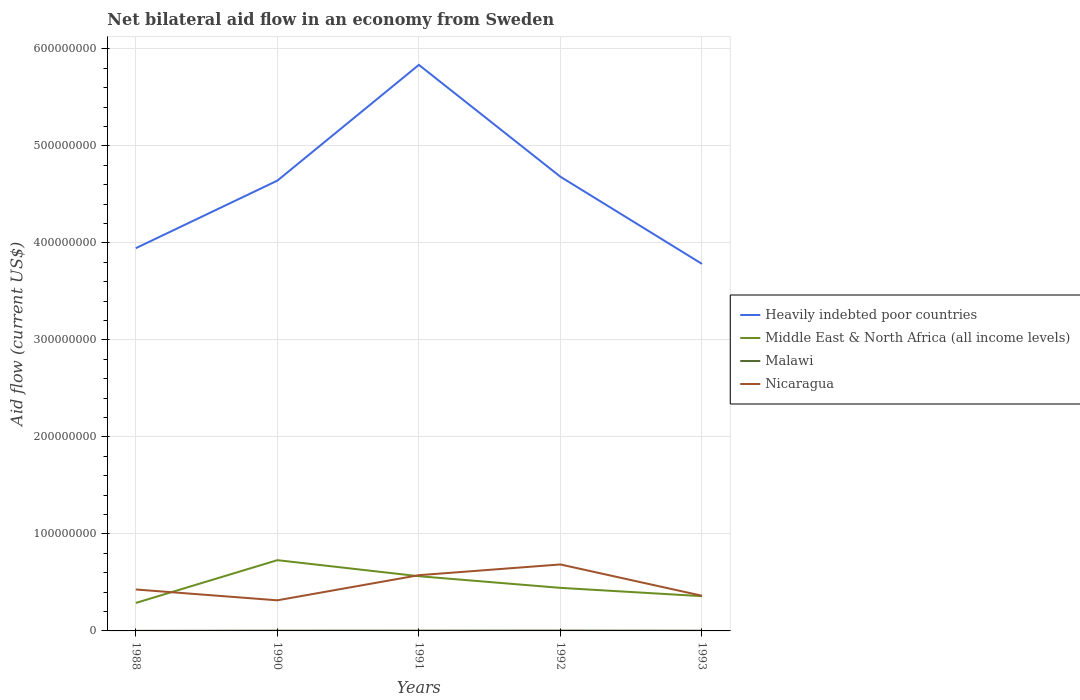Does the line corresponding to Nicaragua intersect with the line corresponding to Malawi?
Make the answer very short. No. In which year was the net bilateral aid flow in Heavily indebted poor countries maximum?
Provide a succinct answer. 1993. What is the total net bilateral aid flow in Middle East & North Africa (all income levels) in the graph?
Your answer should be very brief. 2.06e+07. What is the difference between the highest and the second highest net bilateral aid flow in Nicaragua?
Keep it short and to the point. 3.70e+07. How many years are there in the graph?
Make the answer very short. 5. What is the difference between two consecutive major ticks on the Y-axis?
Your answer should be very brief. 1.00e+08. Are the values on the major ticks of Y-axis written in scientific E-notation?
Keep it short and to the point. No. Does the graph contain grids?
Provide a succinct answer. Yes. Where does the legend appear in the graph?
Provide a succinct answer. Center right. How many legend labels are there?
Your answer should be compact. 4. How are the legend labels stacked?
Your answer should be very brief. Vertical. What is the title of the graph?
Your answer should be compact. Net bilateral aid flow in an economy from Sweden. What is the label or title of the Y-axis?
Ensure brevity in your answer.  Aid flow (current US$). What is the Aid flow (current US$) in Heavily indebted poor countries in 1988?
Make the answer very short. 3.95e+08. What is the Aid flow (current US$) in Middle East & North Africa (all income levels) in 1988?
Provide a short and direct response. 2.88e+07. What is the Aid flow (current US$) of Nicaragua in 1988?
Your answer should be very brief. 4.27e+07. What is the Aid flow (current US$) in Heavily indebted poor countries in 1990?
Make the answer very short. 4.64e+08. What is the Aid flow (current US$) in Middle East & North Africa (all income levels) in 1990?
Provide a succinct answer. 7.29e+07. What is the Aid flow (current US$) in Nicaragua in 1990?
Give a very brief answer. 3.16e+07. What is the Aid flow (current US$) in Heavily indebted poor countries in 1991?
Offer a terse response. 5.84e+08. What is the Aid flow (current US$) in Middle East & North Africa (all income levels) in 1991?
Make the answer very short. 5.64e+07. What is the Aid flow (current US$) in Malawi in 1991?
Provide a short and direct response. 2.90e+05. What is the Aid flow (current US$) in Nicaragua in 1991?
Make the answer very short. 5.75e+07. What is the Aid flow (current US$) of Heavily indebted poor countries in 1992?
Provide a short and direct response. 4.68e+08. What is the Aid flow (current US$) in Middle East & North Africa (all income levels) in 1992?
Keep it short and to the point. 4.44e+07. What is the Aid flow (current US$) in Malawi in 1992?
Your answer should be very brief. 3.50e+05. What is the Aid flow (current US$) of Nicaragua in 1992?
Your answer should be compact. 6.85e+07. What is the Aid flow (current US$) of Heavily indebted poor countries in 1993?
Keep it short and to the point. 3.78e+08. What is the Aid flow (current US$) in Middle East & North Africa (all income levels) in 1993?
Your answer should be very brief. 3.58e+07. What is the Aid flow (current US$) in Nicaragua in 1993?
Keep it short and to the point. 3.63e+07. Across all years, what is the maximum Aid flow (current US$) in Heavily indebted poor countries?
Your response must be concise. 5.84e+08. Across all years, what is the maximum Aid flow (current US$) in Middle East & North Africa (all income levels)?
Your answer should be very brief. 7.29e+07. Across all years, what is the maximum Aid flow (current US$) in Malawi?
Offer a terse response. 3.50e+05. Across all years, what is the maximum Aid flow (current US$) of Nicaragua?
Provide a short and direct response. 6.85e+07. Across all years, what is the minimum Aid flow (current US$) in Heavily indebted poor countries?
Ensure brevity in your answer.  3.78e+08. Across all years, what is the minimum Aid flow (current US$) of Middle East & North Africa (all income levels)?
Provide a succinct answer. 2.88e+07. Across all years, what is the minimum Aid flow (current US$) in Malawi?
Provide a short and direct response. 8.00e+04. Across all years, what is the minimum Aid flow (current US$) of Nicaragua?
Keep it short and to the point. 3.16e+07. What is the total Aid flow (current US$) in Heavily indebted poor countries in the graph?
Your response must be concise. 2.29e+09. What is the total Aid flow (current US$) in Middle East & North Africa (all income levels) in the graph?
Keep it short and to the point. 2.38e+08. What is the total Aid flow (current US$) in Malawi in the graph?
Your answer should be very brief. 1.19e+06. What is the total Aid flow (current US$) of Nicaragua in the graph?
Provide a short and direct response. 2.37e+08. What is the difference between the Aid flow (current US$) in Heavily indebted poor countries in 1988 and that in 1990?
Your answer should be compact. -6.96e+07. What is the difference between the Aid flow (current US$) of Middle East & North Africa (all income levels) in 1988 and that in 1990?
Provide a short and direct response. -4.41e+07. What is the difference between the Aid flow (current US$) of Malawi in 1988 and that in 1990?
Your answer should be compact. -1.70e+05. What is the difference between the Aid flow (current US$) of Nicaragua in 1988 and that in 1990?
Ensure brevity in your answer.  1.12e+07. What is the difference between the Aid flow (current US$) of Heavily indebted poor countries in 1988 and that in 1991?
Keep it short and to the point. -1.89e+08. What is the difference between the Aid flow (current US$) in Middle East & North Africa (all income levels) in 1988 and that in 1991?
Give a very brief answer. -2.76e+07. What is the difference between the Aid flow (current US$) in Nicaragua in 1988 and that in 1991?
Offer a very short reply. -1.47e+07. What is the difference between the Aid flow (current US$) in Heavily indebted poor countries in 1988 and that in 1992?
Your response must be concise. -7.37e+07. What is the difference between the Aid flow (current US$) in Middle East & North Africa (all income levels) in 1988 and that in 1992?
Provide a succinct answer. -1.56e+07. What is the difference between the Aid flow (current US$) of Malawi in 1988 and that in 1992?
Ensure brevity in your answer.  -2.70e+05. What is the difference between the Aid flow (current US$) in Nicaragua in 1988 and that in 1992?
Give a very brief answer. -2.58e+07. What is the difference between the Aid flow (current US$) of Heavily indebted poor countries in 1988 and that in 1993?
Your response must be concise. 1.62e+07. What is the difference between the Aid flow (current US$) in Middle East & North Africa (all income levels) in 1988 and that in 1993?
Make the answer very short. -6.98e+06. What is the difference between the Aid flow (current US$) of Nicaragua in 1988 and that in 1993?
Make the answer very short. 6.46e+06. What is the difference between the Aid flow (current US$) of Heavily indebted poor countries in 1990 and that in 1991?
Offer a very short reply. -1.19e+08. What is the difference between the Aid flow (current US$) in Middle East & North Africa (all income levels) in 1990 and that in 1991?
Give a very brief answer. 1.66e+07. What is the difference between the Aid flow (current US$) of Nicaragua in 1990 and that in 1991?
Provide a succinct answer. -2.59e+07. What is the difference between the Aid flow (current US$) of Heavily indebted poor countries in 1990 and that in 1992?
Your answer should be very brief. -4.04e+06. What is the difference between the Aid flow (current US$) in Middle East & North Africa (all income levels) in 1990 and that in 1992?
Ensure brevity in your answer.  2.86e+07. What is the difference between the Aid flow (current US$) of Malawi in 1990 and that in 1992?
Your response must be concise. -1.00e+05. What is the difference between the Aid flow (current US$) of Nicaragua in 1990 and that in 1992?
Your answer should be very brief. -3.70e+07. What is the difference between the Aid flow (current US$) in Heavily indebted poor countries in 1990 and that in 1993?
Provide a short and direct response. 8.58e+07. What is the difference between the Aid flow (current US$) of Middle East & North Africa (all income levels) in 1990 and that in 1993?
Make the answer very short. 3.71e+07. What is the difference between the Aid flow (current US$) in Nicaragua in 1990 and that in 1993?
Your response must be concise. -4.70e+06. What is the difference between the Aid flow (current US$) in Heavily indebted poor countries in 1991 and that in 1992?
Provide a short and direct response. 1.15e+08. What is the difference between the Aid flow (current US$) of Malawi in 1991 and that in 1992?
Offer a terse response. -6.00e+04. What is the difference between the Aid flow (current US$) of Nicaragua in 1991 and that in 1992?
Ensure brevity in your answer.  -1.11e+07. What is the difference between the Aid flow (current US$) in Heavily indebted poor countries in 1991 and that in 1993?
Give a very brief answer. 2.05e+08. What is the difference between the Aid flow (current US$) of Middle East & North Africa (all income levels) in 1991 and that in 1993?
Provide a succinct answer. 2.06e+07. What is the difference between the Aid flow (current US$) of Malawi in 1991 and that in 1993?
Ensure brevity in your answer.  7.00e+04. What is the difference between the Aid flow (current US$) in Nicaragua in 1991 and that in 1993?
Your answer should be compact. 2.12e+07. What is the difference between the Aid flow (current US$) of Heavily indebted poor countries in 1992 and that in 1993?
Offer a terse response. 8.98e+07. What is the difference between the Aid flow (current US$) of Middle East & North Africa (all income levels) in 1992 and that in 1993?
Give a very brief answer. 8.57e+06. What is the difference between the Aid flow (current US$) of Nicaragua in 1992 and that in 1993?
Offer a very short reply. 3.23e+07. What is the difference between the Aid flow (current US$) in Heavily indebted poor countries in 1988 and the Aid flow (current US$) in Middle East & North Africa (all income levels) in 1990?
Your response must be concise. 3.22e+08. What is the difference between the Aid flow (current US$) in Heavily indebted poor countries in 1988 and the Aid flow (current US$) in Malawi in 1990?
Ensure brevity in your answer.  3.94e+08. What is the difference between the Aid flow (current US$) in Heavily indebted poor countries in 1988 and the Aid flow (current US$) in Nicaragua in 1990?
Provide a short and direct response. 3.63e+08. What is the difference between the Aid flow (current US$) in Middle East & North Africa (all income levels) in 1988 and the Aid flow (current US$) in Malawi in 1990?
Give a very brief answer. 2.86e+07. What is the difference between the Aid flow (current US$) in Middle East & North Africa (all income levels) in 1988 and the Aid flow (current US$) in Nicaragua in 1990?
Provide a succinct answer. -2.72e+06. What is the difference between the Aid flow (current US$) of Malawi in 1988 and the Aid flow (current US$) of Nicaragua in 1990?
Give a very brief answer. -3.15e+07. What is the difference between the Aid flow (current US$) of Heavily indebted poor countries in 1988 and the Aid flow (current US$) of Middle East & North Africa (all income levels) in 1991?
Give a very brief answer. 3.38e+08. What is the difference between the Aid flow (current US$) of Heavily indebted poor countries in 1988 and the Aid flow (current US$) of Malawi in 1991?
Offer a very short reply. 3.94e+08. What is the difference between the Aid flow (current US$) in Heavily indebted poor countries in 1988 and the Aid flow (current US$) in Nicaragua in 1991?
Provide a succinct answer. 3.37e+08. What is the difference between the Aid flow (current US$) of Middle East & North Africa (all income levels) in 1988 and the Aid flow (current US$) of Malawi in 1991?
Offer a very short reply. 2.86e+07. What is the difference between the Aid flow (current US$) in Middle East & North Africa (all income levels) in 1988 and the Aid flow (current US$) in Nicaragua in 1991?
Offer a very short reply. -2.86e+07. What is the difference between the Aid flow (current US$) in Malawi in 1988 and the Aid flow (current US$) in Nicaragua in 1991?
Provide a succinct answer. -5.74e+07. What is the difference between the Aid flow (current US$) of Heavily indebted poor countries in 1988 and the Aid flow (current US$) of Middle East & North Africa (all income levels) in 1992?
Offer a very short reply. 3.50e+08. What is the difference between the Aid flow (current US$) of Heavily indebted poor countries in 1988 and the Aid flow (current US$) of Malawi in 1992?
Make the answer very short. 3.94e+08. What is the difference between the Aid flow (current US$) of Heavily indebted poor countries in 1988 and the Aid flow (current US$) of Nicaragua in 1992?
Make the answer very short. 3.26e+08. What is the difference between the Aid flow (current US$) in Middle East & North Africa (all income levels) in 1988 and the Aid flow (current US$) in Malawi in 1992?
Offer a terse response. 2.85e+07. What is the difference between the Aid flow (current US$) of Middle East & North Africa (all income levels) in 1988 and the Aid flow (current US$) of Nicaragua in 1992?
Ensure brevity in your answer.  -3.97e+07. What is the difference between the Aid flow (current US$) of Malawi in 1988 and the Aid flow (current US$) of Nicaragua in 1992?
Offer a very short reply. -6.84e+07. What is the difference between the Aid flow (current US$) of Heavily indebted poor countries in 1988 and the Aid flow (current US$) of Middle East & North Africa (all income levels) in 1993?
Offer a very short reply. 3.59e+08. What is the difference between the Aid flow (current US$) of Heavily indebted poor countries in 1988 and the Aid flow (current US$) of Malawi in 1993?
Provide a succinct answer. 3.94e+08. What is the difference between the Aid flow (current US$) in Heavily indebted poor countries in 1988 and the Aid flow (current US$) in Nicaragua in 1993?
Your answer should be compact. 3.58e+08. What is the difference between the Aid flow (current US$) of Middle East & North Africa (all income levels) in 1988 and the Aid flow (current US$) of Malawi in 1993?
Give a very brief answer. 2.86e+07. What is the difference between the Aid flow (current US$) of Middle East & North Africa (all income levels) in 1988 and the Aid flow (current US$) of Nicaragua in 1993?
Ensure brevity in your answer.  -7.42e+06. What is the difference between the Aid flow (current US$) in Malawi in 1988 and the Aid flow (current US$) in Nicaragua in 1993?
Offer a very short reply. -3.62e+07. What is the difference between the Aid flow (current US$) in Heavily indebted poor countries in 1990 and the Aid flow (current US$) in Middle East & North Africa (all income levels) in 1991?
Your answer should be very brief. 4.08e+08. What is the difference between the Aid flow (current US$) of Heavily indebted poor countries in 1990 and the Aid flow (current US$) of Malawi in 1991?
Provide a succinct answer. 4.64e+08. What is the difference between the Aid flow (current US$) of Heavily indebted poor countries in 1990 and the Aid flow (current US$) of Nicaragua in 1991?
Provide a short and direct response. 4.07e+08. What is the difference between the Aid flow (current US$) of Middle East & North Africa (all income levels) in 1990 and the Aid flow (current US$) of Malawi in 1991?
Provide a short and direct response. 7.26e+07. What is the difference between the Aid flow (current US$) of Middle East & North Africa (all income levels) in 1990 and the Aid flow (current US$) of Nicaragua in 1991?
Give a very brief answer. 1.55e+07. What is the difference between the Aid flow (current US$) of Malawi in 1990 and the Aid flow (current US$) of Nicaragua in 1991?
Offer a very short reply. -5.72e+07. What is the difference between the Aid flow (current US$) in Heavily indebted poor countries in 1990 and the Aid flow (current US$) in Middle East & North Africa (all income levels) in 1992?
Offer a terse response. 4.20e+08. What is the difference between the Aid flow (current US$) of Heavily indebted poor countries in 1990 and the Aid flow (current US$) of Malawi in 1992?
Offer a very short reply. 4.64e+08. What is the difference between the Aid flow (current US$) of Heavily indebted poor countries in 1990 and the Aid flow (current US$) of Nicaragua in 1992?
Your answer should be compact. 3.96e+08. What is the difference between the Aid flow (current US$) in Middle East & North Africa (all income levels) in 1990 and the Aid flow (current US$) in Malawi in 1992?
Your response must be concise. 7.26e+07. What is the difference between the Aid flow (current US$) in Middle East & North Africa (all income levels) in 1990 and the Aid flow (current US$) in Nicaragua in 1992?
Your response must be concise. 4.42e+06. What is the difference between the Aid flow (current US$) in Malawi in 1990 and the Aid flow (current US$) in Nicaragua in 1992?
Ensure brevity in your answer.  -6.83e+07. What is the difference between the Aid flow (current US$) of Heavily indebted poor countries in 1990 and the Aid flow (current US$) of Middle East & North Africa (all income levels) in 1993?
Keep it short and to the point. 4.28e+08. What is the difference between the Aid flow (current US$) of Heavily indebted poor countries in 1990 and the Aid flow (current US$) of Malawi in 1993?
Provide a short and direct response. 4.64e+08. What is the difference between the Aid flow (current US$) of Heavily indebted poor countries in 1990 and the Aid flow (current US$) of Nicaragua in 1993?
Make the answer very short. 4.28e+08. What is the difference between the Aid flow (current US$) of Middle East & North Africa (all income levels) in 1990 and the Aid flow (current US$) of Malawi in 1993?
Provide a short and direct response. 7.27e+07. What is the difference between the Aid flow (current US$) of Middle East & North Africa (all income levels) in 1990 and the Aid flow (current US$) of Nicaragua in 1993?
Keep it short and to the point. 3.67e+07. What is the difference between the Aid flow (current US$) in Malawi in 1990 and the Aid flow (current US$) in Nicaragua in 1993?
Offer a terse response. -3.60e+07. What is the difference between the Aid flow (current US$) in Heavily indebted poor countries in 1991 and the Aid flow (current US$) in Middle East & North Africa (all income levels) in 1992?
Offer a terse response. 5.39e+08. What is the difference between the Aid flow (current US$) of Heavily indebted poor countries in 1991 and the Aid flow (current US$) of Malawi in 1992?
Provide a short and direct response. 5.83e+08. What is the difference between the Aid flow (current US$) of Heavily indebted poor countries in 1991 and the Aid flow (current US$) of Nicaragua in 1992?
Ensure brevity in your answer.  5.15e+08. What is the difference between the Aid flow (current US$) in Middle East & North Africa (all income levels) in 1991 and the Aid flow (current US$) in Malawi in 1992?
Your answer should be compact. 5.60e+07. What is the difference between the Aid flow (current US$) in Middle East & North Africa (all income levels) in 1991 and the Aid flow (current US$) in Nicaragua in 1992?
Keep it short and to the point. -1.21e+07. What is the difference between the Aid flow (current US$) of Malawi in 1991 and the Aid flow (current US$) of Nicaragua in 1992?
Provide a short and direct response. -6.82e+07. What is the difference between the Aid flow (current US$) in Heavily indebted poor countries in 1991 and the Aid flow (current US$) in Middle East & North Africa (all income levels) in 1993?
Ensure brevity in your answer.  5.48e+08. What is the difference between the Aid flow (current US$) of Heavily indebted poor countries in 1991 and the Aid flow (current US$) of Malawi in 1993?
Offer a very short reply. 5.83e+08. What is the difference between the Aid flow (current US$) in Heavily indebted poor countries in 1991 and the Aid flow (current US$) in Nicaragua in 1993?
Provide a short and direct response. 5.47e+08. What is the difference between the Aid flow (current US$) in Middle East & North Africa (all income levels) in 1991 and the Aid flow (current US$) in Malawi in 1993?
Provide a short and direct response. 5.62e+07. What is the difference between the Aid flow (current US$) of Middle East & North Africa (all income levels) in 1991 and the Aid flow (current US$) of Nicaragua in 1993?
Provide a succinct answer. 2.01e+07. What is the difference between the Aid flow (current US$) in Malawi in 1991 and the Aid flow (current US$) in Nicaragua in 1993?
Your answer should be compact. -3.60e+07. What is the difference between the Aid flow (current US$) of Heavily indebted poor countries in 1992 and the Aid flow (current US$) of Middle East & North Africa (all income levels) in 1993?
Offer a very short reply. 4.32e+08. What is the difference between the Aid flow (current US$) in Heavily indebted poor countries in 1992 and the Aid flow (current US$) in Malawi in 1993?
Your response must be concise. 4.68e+08. What is the difference between the Aid flow (current US$) of Heavily indebted poor countries in 1992 and the Aid flow (current US$) of Nicaragua in 1993?
Ensure brevity in your answer.  4.32e+08. What is the difference between the Aid flow (current US$) in Middle East & North Africa (all income levels) in 1992 and the Aid flow (current US$) in Malawi in 1993?
Provide a succinct answer. 4.42e+07. What is the difference between the Aid flow (current US$) in Middle East & North Africa (all income levels) in 1992 and the Aid flow (current US$) in Nicaragua in 1993?
Provide a succinct answer. 8.13e+06. What is the difference between the Aid flow (current US$) in Malawi in 1992 and the Aid flow (current US$) in Nicaragua in 1993?
Offer a very short reply. -3.59e+07. What is the average Aid flow (current US$) in Heavily indebted poor countries per year?
Make the answer very short. 4.58e+08. What is the average Aid flow (current US$) in Middle East & North Africa (all income levels) per year?
Offer a terse response. 4.77e+07. What is the average Aid flow (current US$) of Malawi per year?
Your response must be concise. 2.38e+05. What is the average Aid flow (current US$) of Nicaragua per year?
Provide a succinct answer. 4.73e+07. In the year 1988, what is the difference between the Aid flow (current US$) of Heavily indebted poor countries and Aid flow (current US$) of Middle East & North Africa (all income levels)?
Your response must be concise. 3.66e+08. In the year 1988, what is the difference between the Aid flow (current US$) of Heavily indebted poor countries and Aid flow (current US$) of Malawi?
Offer a very short reply. 3.94e+08. In the year 1988, what is the difference between the Aid flow (current US$) of Heavily indebted poor countries and Aid flow (current US$) of Nicaragua?
Your answer should be compact. 3.52e+08. In the year 1988, what is the difference between the Aid flow (current US$) in Middle East & North Africa (all income levels) and Aid flow (current US$) in Malawi?
Provide a short and direct response. 2.88e+07. In the year 1988, what is the difference between the Aid flow (current US$) of Middle East & North Africa (all income levels) and Aid flow (current US$) of Nicaragua?
Make the answer very short. -1.39e+07. In the year 1988, what is the difference between the Aid flow (current US$) of Malawi and Aid flow (current US$) of Nicaragua?
Provide a short and direct response. -4.26e+07. In the year 1990, what is the difference between the Aid flow (current US$) of Heavily indebted poor countries and Aid flow (current US$) of Middle East & North Africa (all income levels)?
Your answer should be very brief. 3.91e+08. In the year 1990, what is the difference between the Aid flow (current US$) in Heavily indebted poor countries and Aid flow (current US$) in Malawi?
Provide a succinct answer. 4.64e+08. In the year 1990, what is the difference between the Aid flow (current US$) in Heavily indebted poor countries and Aid flow (current US$) in Nicaragua?
Make the answer very short. 4.33e+08. In the year 1990, what is the difference between the Aid flow (current US$) of Middle East & North Africa (all income levels) and Aid flow (current US$) of Malawi?
Your answer should be compact. 7.27e+07. In the year 1990, what is the difference between the Aid flow (current US$) in Middle East & North Africa (all income levels) and Aid flow (current US$) in Nicaragua?
Your answer should be compact. 4.14e+07. In the year 1990, what is the difference between the Aid flow (current US$) in Malawi and Aid flow (current US$) in Nicaragua?
Your answer should be compact. -3.13e+07. In the year 1991, what is the difference between the Aid flow (current US$) of Heavily indebted poor countries and Aid flow (current US$) of Middle East & North Africa (all income levels)?
Keep it short and to the point. 5.27e+08. In the year 1991, what is the difference between the Aid flow (current US$) of Heavily indebted poor countries and Aid flow (current US$) of Malawi?
Keep it short and to the point. 5.83e+08. In the year 1991, what is the difference between the Aid flow (current US$) of Heavily indebted poor countries and Aid flow (current US$) of Nicaragua?
Your answer should be compact. 5.26e+08. In the year 1991, what is the difference between the Aid flow (current US$) in Middle East & North Africa (all income levels) and Aid flow (current US$) in Malawi?
Give a very brief answer. 5.61e+07. In the year 1991, what is the difference between the Aid flow (current US$) in Middle East & North Africa (all income levels) and Aid flow (current US$) in Nicaragua?
Offer a terse response. -1.07e+06. In the year 1991, what is the difference between the Aid flow (current US$) of Malawi and Aid flow (current US$) of Nicaragua?
Make the answer very short. -5.72e+07. In the year 1992, what is the difference between the Aid flow (current US$) of Heavily indebted poor countries and Aid flow (current US$) of Middle East & North Africa (all income levels)?
Keep it short and to the point. 4.24e+08. In the year 1992, what is the difference between the Aid flow (current US$) of Heavily indebted poor countries and Aid flow (current US$) of Malawi?
Provide a short and direct response. 4.68e+08. In the year 1992, what is the difference between the Aid flow (current US$) in Heavily indebted poor countries and Aid flow (current US$) in Nicaragua?
Give a very brief answer. 4.00e+08. In the year 1992, what is the difference between the Aid flow (current US$) in Middle East & North Africa (all income levels) and Aid flow (current US$) in Malawi?
Give a very brief answer. 4.40e+07. In the year 1992, what is the difference between the Aid flow (current US$) in Middle East & North Africa (all income levels) and Aid flow (current US$) in Nicaragua?
Your response must be concise. -2.41e+07. In the year 1992, what is the difference between the Aid flow (current US$) in Malawi and Aid flow (current US$) in Nicaragua?
Your response must be concise. -6.82e+07. In the year 1993, what is the difference between the Aid flow (current US$) in Heavily indebted poor countries and Aid flow (current US$) in Middle East & North Africa (all income levels)?
Provide a succinct answer. 3.43e+08. In the year 1993, what is the difference between the Aid flow (current US$) in Heavily indebted poor countries and Aid flow (current US$) in Malawi?
Offer a very short reply. 3.78e+08. In the year 1993, what is the difference between the Aid flow (current US$) of Heavily indebted poor countries and Aid flow (current US$) of Nicaragua?
Offer a very short reply. 3.42e+08. In the year 1993, what is the difference between the Aid flow (current US$) of Middle East & North Africa (all income levels) and Aid flow (current US$) of Malawi?
Give a very brief answer. 3.56e+07. In the year 1993, what is the difference between the Aid flow (current US$) in Middle East & North Africa (all income levels) and Aid flow (current US$) in Nicaragua?
Ensure brevity in your answer.  -4.40e+05. In the year 1993, what is the difference between the Aid flow (current US$) in Malawi and Aid flow (current US$) in Nicaragua?
Give a very brief answer. -3.60e+07. What is the ratio of the Aid flow (current US$) in Middle East & North Africa (all income levels) in 1988 to that in 1990?
Make the answer very short. 0.4. What is the ratio of the Aid flow (current US$) in Malawi in 1988 to that in 1990?
Ensure brevity in your answer.  0.32. What is the ratio of the Aid flow (current US$) in Nicaragua in 1988 to that in 1990?
Offer a terse response. 1.35. What is the ratio of the Aid flow (current US$) of Heavily indebted poor countries in 1988 to that in 1991?
Your answer should be compact. 0.68. What is the ratio of the Aid flow (current US$) of Middle East & North Africa (all income levels) in 1988 to that in 1991?
Your response must be concise. 0.51. What is the ratio of the Aid flow (current US$) of Malawi in 1988 to that in 1991?
Provide a succinct answer. 0.28. What is the ratio of the Aid flow (current US$) of Nicaragua in 1988 to that in 1991?
Your answer should be very brief. 0.74. What is the ratio of the Aid flow (current US$) of Heavily indebted poor countries in 1988 to that in 1992?
Provide a short and direct response. 0.84. What is the ratio of the Aid flow (current US$) of Middle East & North Africa (all income levels) in 1988 to that in 1992?
Your answer should be compact. 0.65. What is the ratio of the Aid flow (current US$) of Malawi in 1988 to that in 1992?
Your answer should be very brief. 0.23. What is the ratio of the Aid flow (current US$) of Nicaragua in 1988 to that in 1992?
Provide a succinct answer. 0.62. What is the ratio of the Aid flow (current US$) in Heavily indebted poor countries in 1988 to that in 1993?
Provide a short and direct response. 1.04. What is the ratio of the Aid flow (current US$) of Middle East & North Africa (all income levels) in 1988 to that in 1993?
Offer a very short reply. 0.81. What is the ratio of the Aid flow (current US$) in Malawi in 1988 to that in 1993?
Give a very brief answer. 0.36. What is the ratio of the Aid flow (current US$) in Nicaragua in 1988 to that in 1993?
Offer a terse response. 1.18. What is the ratio of the Aid flow (current US$) of Heavily indebted poor countries in 1990 to that in 1991?
Offer a very short reply. 0.8. What is the ratio of the Aid flow (current US$) of Middle East & North Africa (all income levels) in 1990 to that in 1991?
Your response must be concise. 1.29. What is the ratio of the Aid flow (current US$) in Malawi in 1990 to that in 1991?
Offer a terse response. 0.86. What is the ratio of the Aid flow (current US$) in Nicaragua in 1990 to that in 1991?
Your answer should be very brief. 0.55. What is the ratio of the Aid flow (current US$) of Heavily indebted poor countries in 1990 to that in 1992?
Your response must be concise. 0.99. What is the ratio of the Aid flow (current US$) in Middle East & North Africa (all income levels) in 1990 to that in 1992?
Give a very brief answer. 1.64. What is the ratio of the Aid flow (current US$) of Malawi in 1990 to that in 1992?
Ensure brevity in your answer.  0.71. What is the ratio of the Aid flow (current US$) in Nicaragua in 1990 to that in 1992?
Give a very brief answer. 0.46. What is the ratio of the Aid flow (current US$) in Heavily indebted poor countries in 1990 to that in 1993?
Your answer should be compact. 1.23. What is the ratio of the Aid flow (current US$) in Middle East & North Africa (all income levels) in 1990 to that in 1993?
Make the answer very short. 2.04. What is the ratio of the Aid flow (current US$) of Malawi in 1990 to that in 1993?
Your answer should be compact. 1.14. What is the ratio of the Aid flow (current US$) in Nicaragua in 1990 to that in 1993?
Offer a terse response. 0.87. What is the ratio of the Aid flow (current US$) in Heavily indebted poor countries in 1991 to that in 1992?
Provide a short and direct response. 1.25. What is the ratio of the Aid flow (current US$) in Middle East & North Africa (all income levels) in 1991 to that in 1992?
Provide a succinct answer. 1.27. What is the ratio of the Aid flow (current US$) in Malawi in 1991 to that in 1992?
Provide a short and direct response. 0.83. What is the ratio of the Aid flow (current US$) in Nicaragua in 1991 to that in 1992?
Offer a very short reply. 0.84. What is the ratio of the Aid flow (current US$) in Heavily indebted poor countries in 1991 to that in 1993?
Provide a short and direct response. 1.54. What is the ratio of the Aid flow (current US$) of Middle East & North Africa (all income levels) in 1991 to that in 1993?
Offer a terse response. 1.57. What is the ratio of the Aid flow (current US$) in Malawi in 1991 to that in 1993?
Provide a short and direct response. 1.32. What is the ratio of the Aid flow (current US$) in Nicaragua in 1991 to that in 1993?
Keep it short and to the point. 1.58. What is the ratio of the Aid flow (current US$) of Heavily indebted poor countries in 1992 to that in 1993?
Offer a terse response. 1.24. What is the ratio of the Aid flow (current US$) in Middle East & North Africa (all income levels) in 1992 to that in 1993?
Your answer should be compact. 1.24. What is the ratio of the Aid flow (current US$) in Malawi in 1992 to that in 1993?
Offer a very short reply. 1.59. What is the ratio of the Aid flow (current US$) in Nicaragua in 1992 to that in 1993?
Your answer should be compact. 1.89. What is the difference between the highest and the second highest Aid flow (current US$) in Heavily indebted poor countries?
Provide a succinct answer. 1.15e+08. What is the difference between the highest and the second highest Aid flow (current US$) of Middle East & North Africa (all income levels)?
Provide a short and direct response. 1.66e+07. What is the difference between the highest and the second highest Aid flow (current US$) in Malawi?
Keep it short and to the point. 6.00e+04. What is the difference between the highest and the second highest Aid flow (current US$) in Nicaragua?
Provide a succinct answer. 1.11e+07. What is the difference between the highest and the lowest Aid flow (current US$) in Heavily indebted poor countries?
Provide a succinct answer. 2.05e+08. What is the difference between the highest and the lowest Aid flow (current US$) of Middle East & North Africa (all income levels)?
Your response must be concise. 4.41e+07. What is the difference between the highest and the lowest Aid flow (current US$) in Nicaragua?
Ensure brevity in your answer.  3.70e+07. 